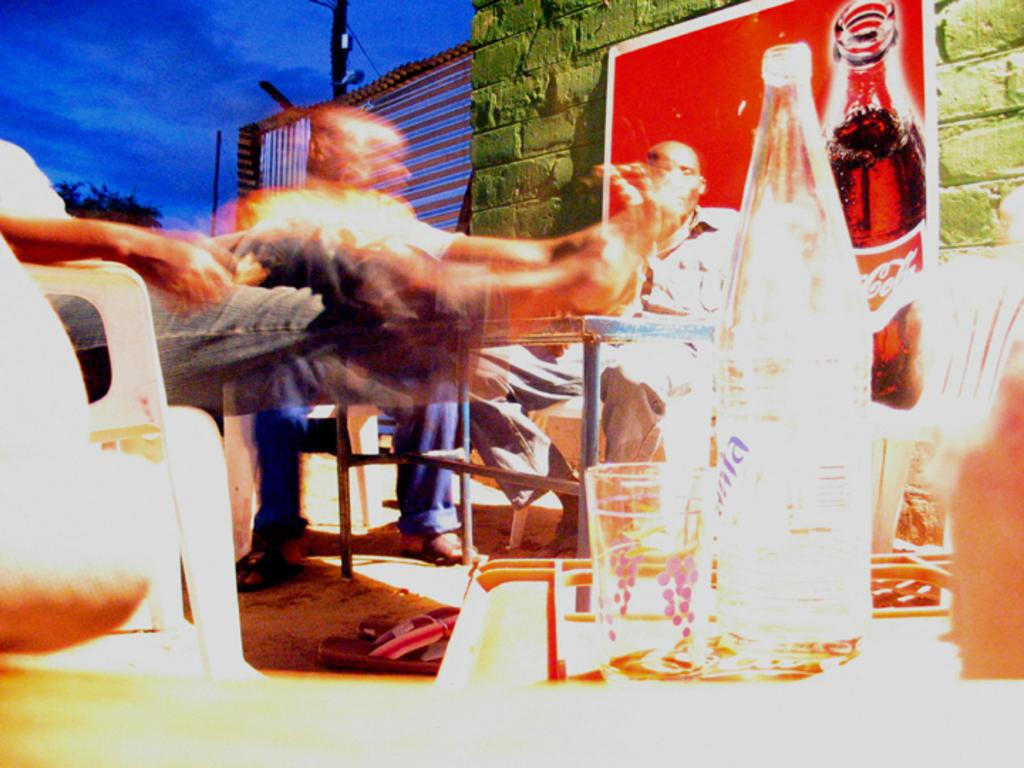How many people are in the image? There are two people in the image. What are the people doing in the image? The people are sitting on a chair. What can be seen in the image besides the people? There is a cool drink bottle in the image. What is visible in the background of the image? There is a sky visible in the background of the image. What type of goat can be seen in the image? There is no goat present in the image. What time of day is it in the image, considering the morning? The time of day cannot be determined from the image, as there are no specific clues or indicators of the time. 